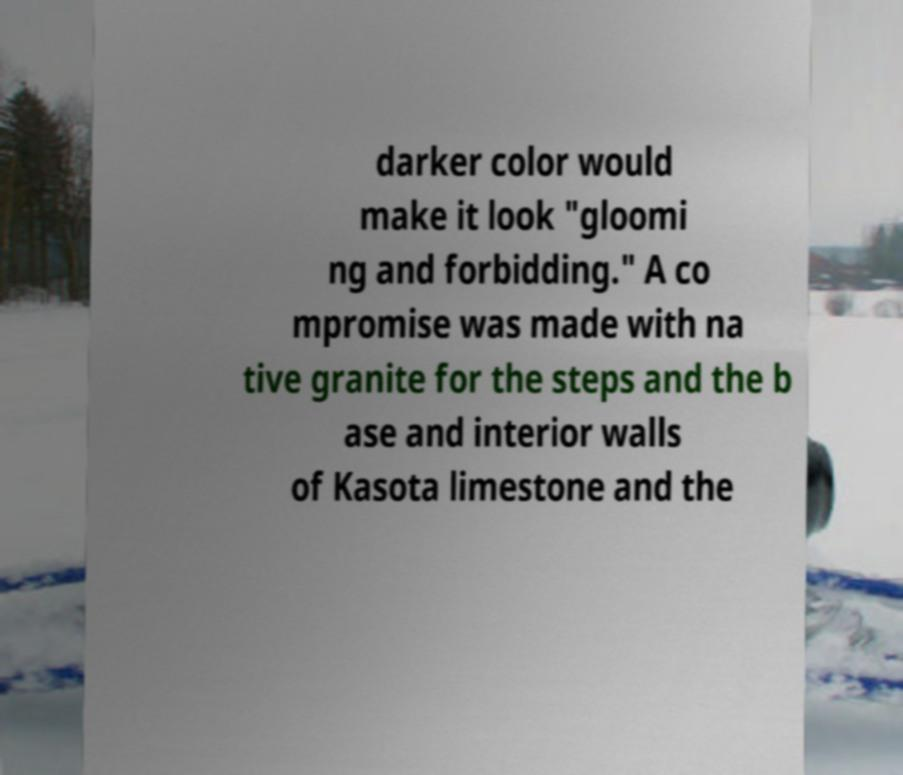I need the written content from this picture converted into text. Can you do that? darker color would make it look "gloomi ng and forbidding." A co mpromise was made with na tive granite for the steps and the b ase and interior walls of Kasota limestone and the 